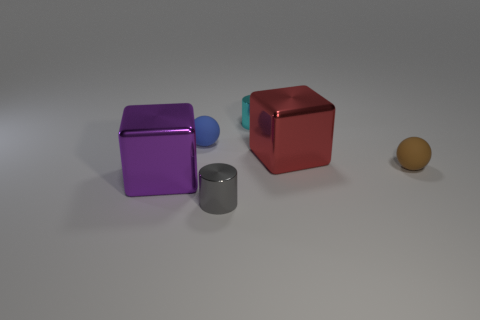Subtract all purple blocks. How many blocks are left? 1 Subtract all balls. How many objects are left? 4 Add 4 tiny cyan metallic cylinders. How many objects exist? 10 Subtract 1 spheres. How many spheres are left? 1 Subtract all blue spheres. How many red blocks are left? 1 Subtract 0 purple spheres. How many objects are left? 6 Subtract all brown cylinders. Subtract all red blocks. How many cylinders are left? 2 Subtract all big purple rubber cubes. Subtract all gray metal objects. How many objects are left? 5 Add 4 small rubber things. How many small rubber things are left? 6 Add 1 large things. How many large things exist? 3 